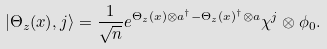<formula> <loc_0><loc_0><loc_500><loc_500>| \Theta _ { z } ( x ) , j \rangle = \frac { 1 } { \sqrt { n } } e ^ { \Theta _ { z } ( x ) \otimes a ^ { \dagger } - \Theta _ { z } ( x ) ^ { \dagger } \otimes a } \chi ^ { j } \otimes \phi _ { 0 } .</formula> 